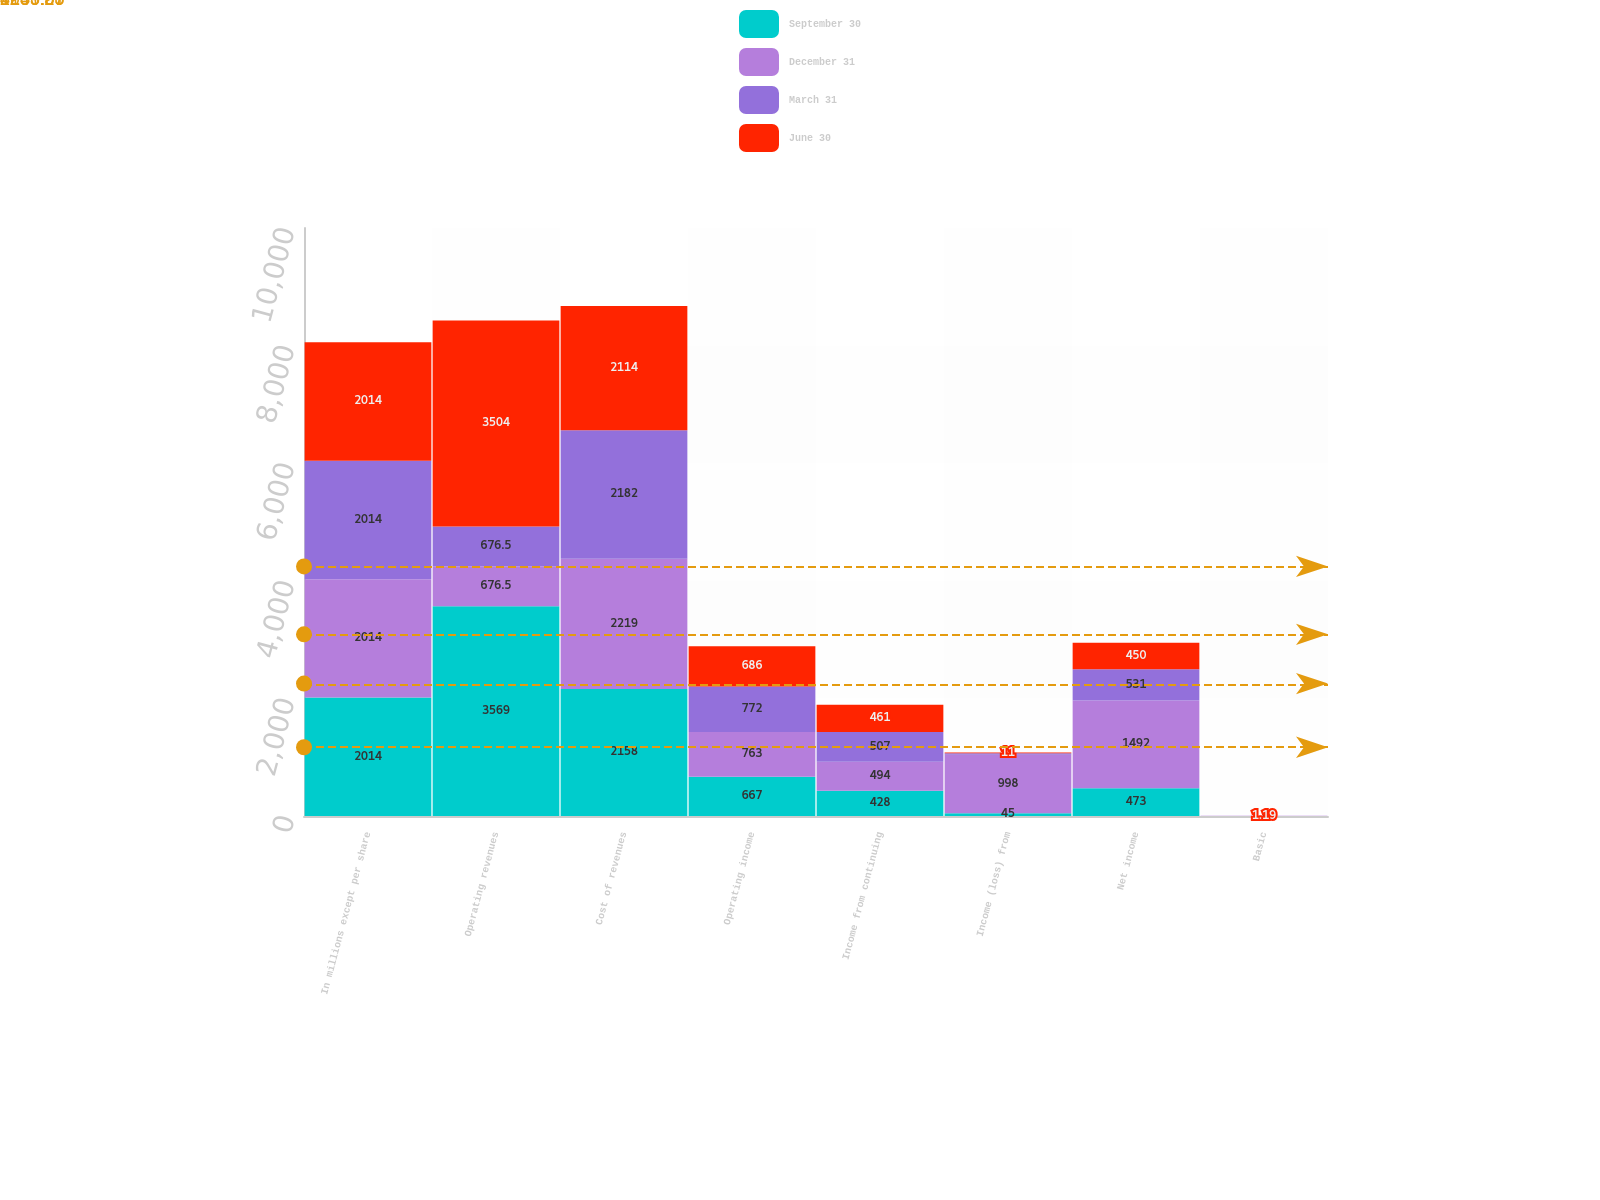Convert chart. <chart><loc_0><loc_0><loc_500><loc_500><stacked_bar_chart><ecel><fcel>In millions except per share<fcel>Operating revenues<fcel>Cost of revenues<fcel>Operating income<fcel>Income from continuing<fcel>Income (loss) from<fcel>Net income<fcel>Basic<nl><fcel>September 30<fcel>2014<fcel>3569<fcel>2158<fcel>667<fcel>428<fcel>45<fcel>473<fcel>1.01<nl><fcel>December 31<fcel>2014<fcel>676.5<fcel>2219<fcel>763<fcel>494<fcel>998<fcel>1492<fcel>1.22<nl><fcel>March 31<fcel>2014<fcel>676.5<fcel>2182<fcel>772<fcel>507<fcel>24<fcel>531<fcel>1.29<nl><fcel>June 30<fcel>2014<fcel>3504<fcel>2114<fcel>686<fcel>461<fcel>11<fcel>450<fcel>1.19<nl></chart> 